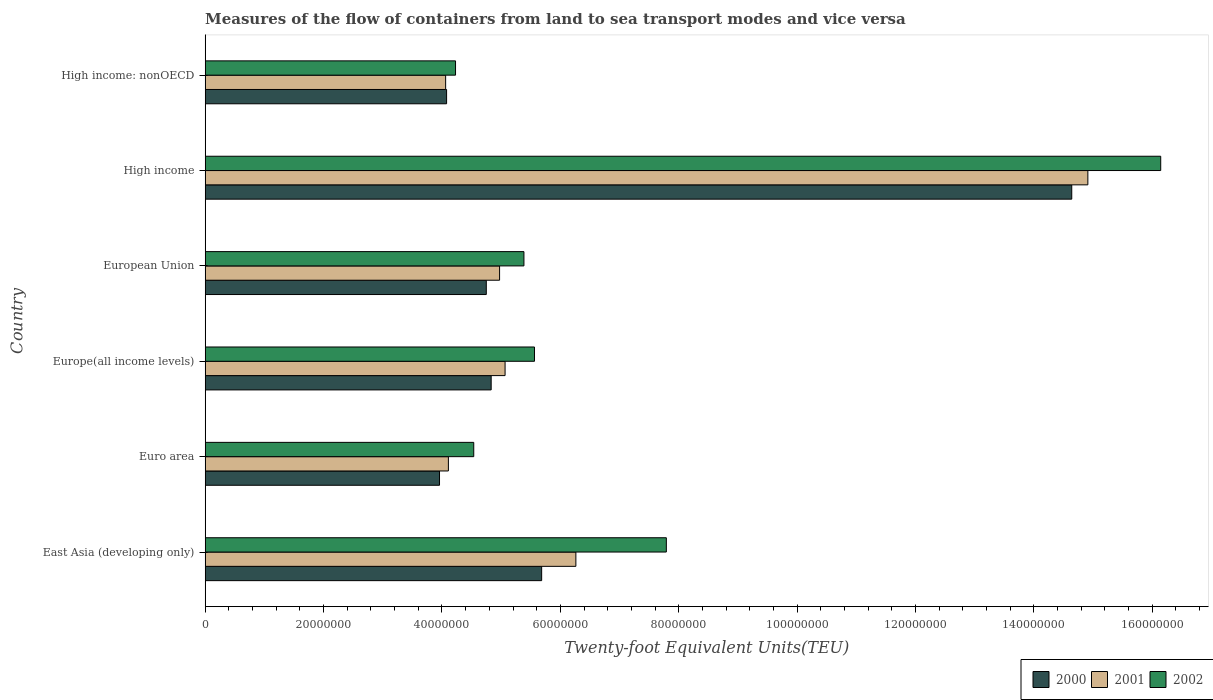How many groups of bars are there?
Give a very brief answer. 6. Are the number of bars per tick equal to the number of legend labels?
Give a very brief answer. Yes. Are the number of bars on each tick of the Y-axis equal?
Ensure brevity in your answer.  Yes. How many bars are there on the 1st tick from the top?
Give a very brief answer. 3. What is the label of the 1st group of bars from the top?
Your answer should be very brief. High income: nonOECD. In how many cases, is the number of bars for a given country not equal to the number of legend labels?
Give a very brief answer. 0. What is the container port traffic in 2000 in Europe(all income levels)?
Offer a very short reply. 4.83e+07. Across all countries, what is the maximum container port traffic in 2001?
Your answer should be very brief. 1.49e+08. Across all countries, what is the minimum container port traffic in 2001?
Offer a terse response. 4.06e+07. In which country was the container port traffic in 2001 minimum?
Offer a very short reply. High income: nonOECD. What is the total container port traffic in 2000 in the graph?
Offer a terse response. 3.79e+08. What is the difference between the container port traffic in 2002 in Euro area and that in High income: nonOECD?
Make the answer very short. 3.08e+06. What is the difference between the container port traffic in 2001 in East Asia (developing only) and the container port traffic in 2002 in High income: nonOECD?
Your response must be concise. 2.03e+07. What is the average container port traffic in 2002 per country?
Your response must be concise. 7.27e+07. What is the difference between the container port traffic in 2000 and container port traffic in 2002 in Europe(all income levels)?
Make the answer very short. -7.32e+06. What is the ratio of the container port traffic in 2002 in Euro area to that in High income?
Your answer should be very brief. 0.28. Is the container port traffic in 2000 in European Union less than that in High income: nonOECD?
Your answer should be compact. No. Is the difference between the container port traffic in 2000 in Euro area and Europe(all income levels) greater than the difference between the container port traffic in 2002 in Euro area and Europe(all income levels)?
Give a very brief answer. Yes. What is the difference between the highest and the second highest container port traffic in 2000?
Provide a succinct answer. 8.96e+07. What is the difference between the highest and the lowest container port traffic in 2000?
Offer a terse response. 1.07e+08. What does the 1st bar from the top in High income represents?
Ensure brevity in your answer.  2002. Is it the case that in every country, the sum of the container port traffic in 2000 and container port traffic in 2002 is greater than the container port traffic in 2001?
Make the answer very short. Yes. How many bars are there?
Your answer should be very brief. 18. Does the graph contain any zero values?
Offer a terse response. No. What is the title of the graph?
Ensure brevity in your answer.  Measures of the flow of containers from land to sea transport modes and vice versa. What is the label or title of the X-axis?
Offer a terse response. Twenty-foot Equivalent Units(TEU). What is the label or title of the Y-axis?
Make the answer very short. Country. What is the Twenty-foot Equivalent Units(TEU) in 2000 in East Asia (developing only)?
Keep it short and to the point. 5.68e+07. What is the Twenty-foot Equivalent Units(TEU) of 2001 in East Asia (developing only)?
Your response must be concise. 6.26e+07. What is the Twenty-foot Equivalent Units(TEU) in 2002 in East Asia (developing only)?
Ensure brevity in your answer.  7.79e+07. What is the Twenty-foot Equivalent Units(TEU) of 2000 in Euro area?
Ensure brevity in your answer.  3.96e+07. What is the Twenty-foot Equivalent Units(TEU) in 2001 in Euro area?
Provide a short and direct response. 4.11e+07. What is the Twenty-foot Equivalent Units(TEU) in 2002 in Euro area?
Offer a terse response. 4.54e+07. What is the Twenty-foot Equivalent Units(TEU) of 2000 in Europe(all income levels)?
Offer a terse response. 4.83e+07. What is the Twenty-foot Equivalent Units(TEU) of 2001 in Europe(all income levels)?
Offer a terse response. 5.07e+07. What is the Twenty-foot Equivalent Units(TEU) of 2002 in Europe(all income levels)?
Provide a short and direct response. 5.56e+07. What is the Twenty-foot Equivalent Units(TEU) in 2000 in European Union?
Provide a succinct answer. 4.75e+07. What is the Twenty-foot Equivalent Units(TEU) of 2001 in European Union?
Offer a terse response. 4.97e+07. What is the Twenty-foot Equivalent Units(TEU) in 2002 in European Union?
Provide a succinct answer. 5.38e+07. What is the Twenty-foot Equivalent Units(TEU) of 2000 in High income?
Keep it short and to the point. 1.46e+08. What is the Twenty-foot Equivalent Units(TEU) in 2001 in High income?
Offer a terse response. 1.49e+08. What is the Twenty-foot Equivalent Units(TEU) of 2002 in High income?
Give a very brief answer. 1.61e+08. What is the Twenty-foot Equivalent Units(TEU) in 2000 in High income: nonOECD?
Your answer should be compact. 4.08e+07. What is the Twenty-foot Equivalent Units(TEU) in 2001 in High income: nonOECD?
Give a very brief answer. 4.06e+07. What is the Twenty-foot Equivalent Units(TEU) in 2002 in High income: nonOECD?
Your response must be concise. 4.23e+07. Across all countries, what is the maximum Twenty-foot Equivalent Units(TEU) in 2000?
Make the answer very short. 1.46e+08. Across all countries, what is the maximum Twenty-foot Equivalent Units(TEU) in 2001?
Give a very brief answer. 1.49e+08. Across all countries, what is the maximum Twenty-foot Equivalent Units(TEU) in 2002?
Your response must be concise. 1.61e+08. Across all countries, what is the minimum Twenty-foot Equivalent Units(TEU) in 2000?
Provide a succinct answer. 3.96e+07. Across all countries, what is the minimum Twenty-foot Equivalent Units(TEU) in 2001?
Give a very brief answer. 4.06e+07. Across all countries, what is the minimum Twenty-foot Equivalent Units(TEU) in 2002?
Provide a succinct answer. 4.23e+07. What is the total Twenty-foot Equivalent Units(TEU) in 2000 in the graph?
Your answer should be very brief. 3.79e+08. What is the total Twenty-foot Equivalent Units(TEU) of 2001 in the graph?
Offer a terse response. 3.94e+08. What is the total Twenty-foot Equivalent Units(TEU) in 2002 in the graph?
Give a very brief answer. 4.36e+08. What is the difference between the Twenty-foot Equivalent Units(TEU) of 2000 in East Asia (developing only) and that in Euro area?
Your answer should be very brief. 1.73e+07. What is the difference between the Twenty-foot Equivalent Units(TEU) in 2001 in East Asia (developing only) and that in Euro area?
Offer a terse response. 2.15e+07. What is the difference between the Twenty-foot Equivalent Units(TEU) of 2002 in East Asia (developing only) and that in Euro area?
Make the answer very short. 3.25e+07. What is the difference between the Twenty-foot Equivalent Units(TEU) of 2000 in East Asia (developing only) and that in Europe(all income levels)?
Provide a short and direct response. 8.53e+06. What is the difference between the Twenty-foot Equivalent Units(TEU) in 2001 in East Asia (developing only) and that in Europe(all income levels)?
Offer a terse response. 1.20e+07. What is the difference between the Twenty-foot Equivalent Units(TEU) of 2002 in East Asia (developing only) and that in Europe(all income levels)?
Offer a terse response. 2.23e+07. What is the difference between the Twenty-foot Equivalent Units(TEU) of 2000 in East Asia (developing only) and that in European Union?
Your answer should be compact. 9.35e+06. What is the difference between the Twenty-foot Equivalent Units(TEU) in 2001 in East Asia (developing only) and that in European Union?
Your answer should be compact. 1.29e+07. What is the difference between the Twenty-foot Equivalent Units(TEU) in 2002 in East Asia (developing only) and that in European Union?
Give a very brief answer. 2.41e+07. What is the difference between the Twenty-foot Equivalent Units(TEU) in 2000 in East Asia (developing only) and that in High income?
Your answer should be very brief. -8.96e+07. What is the difference between the Twenty-foot Equivalent Units(TEU) of 2001 in East Asia (developing only) and that in High income?
Ensure brevity in your answer.  -8.65e+07. What is the difference between the Twenty-foot Equivalent Units(TEU) in 2002 in East Asia (developing only) and that in High income?
Keep it short and to the point. -8.35e+07. What is the difference between the Twenty-foot Equivalent Units(TEU) in 2000 in East Asia (developing only) and that in High income: nonOECD?
Make the answer very short. 1.61e+07. What is the difference between the Twenty-foot Equivalent Units(TEU) of 2001 in East Asia (developing only) and that in High income: nonOECD?
Your response must be concise. 2.20e+07. What is the difference between the Twenty-foot Equivalent Units(TEU) in 2002 in East Asia (developing only) and that in High income: nonOECD?
Your answer should be very brief. 3.56e+07. What is the difference between the Twenty-foot Equivalent Units(TEU) in 2000 in Euro area and that in Europe(all income levels)?
Your answer should be very brief. -8.73e+06. What is the difference between the Twenty-foot Equivalent Units(TEU) in 2001 in Euro area and that in Europe(all income levels)?
Offer a very short reply. -9.58e+06. What is the difference between the Twenty-foot Equivalent Units(TEU) of 2002 in Euro area and that in Europe(all income levels)?
Offer a very short reply. -1.03e+07. What is the difference between the Twenty-foot Equivalent Units(TEU) in 2000 in Euro area and that in European Union?
Provide a succinct answer. -7.90e+06. What is the difference between the Twenty-foot Equivalent Units(TEU) of 2001 in Euro area and that in European Union?
Provide a short and direct response. -8.65e+06. What is the difference between the Twenty-foot Equivalent Units(TEU) in 2002 in Euro area and that in European Union?
Give a very brief answer. -8.48e+06. What is the difference between the Twenty-foot Equivalent Units(TEU) in 2000 in Euro area and that in High income?
Your response must be concise. -1.07e+08. What is the difference between the Twenty-foot Equivalent Units(TEU) in 2001 in Euro area and that in High income?
Keep it short and to the point. -1.08e+08. What is the difference between the Twenty-foot Equivalent Units(TEU) of 2002 in Euro area and that in High income?
Provide a succinct answer. -1.16e+08. What is the difference between the Twenty-foot Equivalent Units(TEU) of 2000 in Euro area and that in High income: nonOECD?
Offer a very short reply. -1.20e+06. What is the difference between the Twenty-foot Equivalent Units(TEU) of 2001 in Euro area and that in High income: nonOECD?
Your answer should be very brief. 4.64e+05. What is the difference between the Twenty-foot Equivalent Units(TEU) of 2002 in Euro area and that in High income: nonOECD?
Offer a very short reply. 3.08e+06. What is the difference between the Twenty-foot Equivalent Units(TEU) in 2000 in Europe(all income levels) and that in European Union?
Provide a short and direct response. 8.26e+05. What is the difference between the Twenty-foot Equivalent Units(TEU) in 2001 in Europe(all income levels) and that in European Union?
Offer a very short reply. 9.30e+05. What is the difference between the Twenty-foot Equivalent Units(TEU) in 2002 in Europe(all income levels) and that in European Union?
Provide a succinct answer. 1.78e+06. What is the difference between the Twenty-foot Equivalent Units(TEU) of 2000 in Europe(all income levels) and that in High income?
Your answer should be compact. -9.81e+07. What is the difference between the Twenty-foot Equivalent Units(TEU) of 2001 in Europe(all income levels) and that in High income?
Provide a short and direct response. -9.85e+07. What is the difference between the Twenty-foot Equivalent Units(TEU) in 2002 in Europe(all income levels) and that in High income?
Give a very brief answer. -1.06e+08. What is the difference between the Twenty-foot Equivalent Units(TEU) in 2000 in Europe(all income levels) and that in High income: nonOECD?
Ensure brevity in your answer.  7.53e+06. What is the difference between the Twenty-foot Equivalent Units(TEU) in 2001 in Europe(all income levels) and that in High income: nonOECD?
Make the answer very short. 1.00e+07. What is the difference between the Twenty-foot Equivalent Units(TEU) of 2002 in Europe(all income levels) and that in High income: nonOECD?
Your answer should be very brief. 1.33e+07. What is the difference between the Twenty-foot Equivalent Units(TEU) of 2000 in European Union and that in High income?
Your answer should be very brief. -9.89e+07. What is the difference between the Twenty-foot Equivalent Units(TEU) of 2001 in European Union and that in High income?
Ensure brevity in your answer.  -9.94e+07. What is the difference between the Twenty-foot Equivalent Units(TEU) in 2002 in European Union and that in High income?
Your answer should be very brief. -1.08e+08. What is the difference between the Twenty-foot Equivalent Units(TEU) of 2000 in European Union and that in High income: nonOECD?
Provide a succinct answer. 6.71e+06. What is the difference between the Twenty-foot Equivalent Units(TEU) of 2001 in European Union and that in High income: nonOECD?
Make the answer very short. 9.11e+06. What is the difference between the Twenty-foot Equivalent Units(TEU) of 2002 in European Union and that in High income: nonOECD?
Keep it short and to the point. 1.16e+07. What is the difference between the Twenty-foot Equivalent Units(TEU) of 2000 in High income and that in High income: nonOECD?
Give a very brief answer. 1.06e+08. What is the difference between the Twenty-foot Equivalent Units(TEU) of 2001 in High income and that in High income: nonOECD?
Make the answer very short. 1.08e+08. What is the difference between the Twenty-foot Equivalent Units(TEU) of 2002 in High income and that in High income: nonOECD?
Ensure brevity in your answer.  1.19e+08. What is the difference between the Twenty-foot Equivalent Units(TEU) in 2000 in East Asia (developing only) and the Twenty-foot Equivalent Units(TEU) in 2001 in Euro area?
Offer a very short reply. 1.58e+07. What is the difference between the Twenty-foot Equivalent Units(TEU) in 2000 in East Asia (developing only) and the Twenty-foot Equivalent Units(TEU) in 2002 in Euro area?
Provide a succinct answer. 1.15e+07. What is the difference between the Twenty-foot Equivalent Units(TEU) in 2001 in East Asia (developing only) and the Twenty-foot Equivalent Units(TEU) in 2002 in Euro area?
Your response must be concise. 1.73e+07. What is the difference between the Twenty-foot Equivalent Units(TEU) in 2000 in East Asia (developing only) and the Twenty-foot Equivalent Units(TEU) in 2001 in Europe(all income levels)?
Provide a short and direct response. 6.18e+06. What is the difference between the Twenty-foot Equivalent Units(TEU) of 2000 in East Asia (developing only) and the Twenty-foot Equivalent Units(TEU) of 2002 in Europe(all income levels)?
Your answer should be very brief. 1.21e+06. What is the difference between the Twenty-foot Equivalent Units(TEU) of 2001 in East Asia (developing only) and the Twenty-foot Equivalent Units(TEU) of 2002 in Europe(all income levels)?
Provide a succinct answer. 6.99e+06. What is the difference between the Twenty-foot Equivalent Units(TEU) of 2000 in East Asia (developing only) and the Twenty-foot Equivalent Units(TEU) of 2001 in European Union?
Offer a very short reply. 7.11e+06. What is the difference between the Twenty-foot Equivalent Units(TEU) in 2000 in East Asia (developing only) and the Twenty-foot Equivalent Units(TEU) in 2002 in European Union?
Provide a succinct answer. 3.00e+06. What is the difference between the Twenty-foot Equivalent Units(TEU) of 2001 in East Asia (developing only) and the Twenty-foot Equivalent Units(TEU) of 2002 in European Union?
Offer a terse response. 8.78e+06. What is the difference between the Twenty-foot Equivalent Units(TEU) in 2000 in East Asia (developing only) and the Twenty-foot Equivalent Units(TEU) in 2001 in High income?
Offer a very short reply. -9.23e+07. What is the difference between the Twenty-foot Equivalent Units(TEU) of 2000 in East Asia (developing only) and the Twenty-foot Equivalent Units(TEU) of 2002 in High income?
Your answer should be very brief. -1.05e+08. What is the difference between the Twenty-foot Equivalent Units(TEU) in 2001 in East Asia (developing only) and the Twenty-foot Equivalent Units(TEU) in 2002 in High income?
Provide a succinct answer. -9.88e+07. What is the difference between the Twenty-foot Equivalent Units(TEU) of 2000 in East Asia (developing only) and the Twenty-foot Equivalent Units(TEU) of 2001 in High income: nonOECD?
Keep it short and to the point. 1.62e+07. What is the difference between the Twenty-foot Equivalent Units(TEU) of 2000 in East Asia (developing only) and the Twenty-foot Equivalent Units(TEU) of 2002 in High income: nonOECD?
Give a very brief answer. 1.45e+07. What is the difference between the Twenty-foot Equivalent Units(TEU) in 2001 in East Asia (developing only) and the Twenty-foot Equivalent Units(TEU) in 2002 in High income: nonOECD?
Ensure brevity in your answer.  2.03e+07. What is the difference between the Twenty-foot Equivalent Units(TEU) of 2000 in Euro area and the Twenty-foot Equivalent Units(TEU) of 2001 in Europe(all income levels)?
Provide a succinct answer. -1.11e+07. What is the difference between the Twenty-foot Equivalent Units(TEU) of 2000 in Euro area and the Twenty-foot Equivalent Units(TEU) of 2002 in Europe(all income levels)?
Offer a very short reply. -1.60e+07. What is the difference between the Twenty-foot Equivalent Units(TEU) in 2001 in Euro area and the Twenty-foot Equivalent Units(TEU) in 2002 in Europe(all income levels)?
Offer a terse response. -1.45e+07. What is the difference between the Twenty-foot Equivalent Units(TEU) of 2000 in Euro area and the Twenty-foot Equivalent Units(TEU) of 2001 in European Union?
Offer a very short reply. -1.01e+07. What is the difference between the Twenty-foot Equivalent Units(TEU) in 2000 in Euro area and the Twenty-foot Equivalent Units(TEU) in 2002 in European Union?
Offer a very short reply. -1.43e+07. What is the difference between the Twenty-foot Equivalent Units(TEU) of 2001 in Euro area and the Twenty-foot Equivalent Units(TEU) of 2002 in European Union?
Your answer should be very brief. -1.28e+07. What is the difference between the Twenty-foot Equivalent Units(TEU) in 2000 in Euro area and the Twenty-foot Equivalent Units(TEU) in 2001 in High income?
Your answer should be very brief. -1.10e+08. What is the difference between the Twenty-foot Equivalent Units(TEU) of 2000 in Euro area and the Twenty-foot Equivalent Units(TEU) of 2002 in High income?
Your answer should be very brief. -1.22e+08. What is the difference between the Twenty-foot Equivalent Units(TEU) in 2001 in Euro area and the Twenty-foot Equivalent Units(TEU) in 2002 in High income?
Ensure brevity in your answer.  -1.20e+08. What is the difference between the Twenty-foot Equivalent Units(TEU) of 2000 in Euro area and the Twenty-foot Equivalent Units(TEU) of 2001 in High income: nonOECD?
Your response must be concise. -1.04e+06. What is the difference between the Twenty-foot Equivalent Units(TEU) in 2000 in Euro area and the Twenty-foot Equivalent Units(TEU) in 2002 in High income: nonOECD?
Your answer should be compact. -2.71e+06. What is the difference between the Twenty-foot Equivalent Units(TEU) in 2001 in Euro area and the Twenty-foot Equivalent Units(TEU) in 2002 in High income: nonOECD?
Offer a terse response. -1.21e+06. What is the difference between the Twenty-foot Equivalent Units(TEU) in 2000 in Europe(all income levels) and the Twenty-foot Equivalent Units(TEU) in 2001 in European Union?
Your answer should be compact. -1.42e+06. What is the difference between the Twenty-foot Equivalent Units(TEU) in 2000 in Europe(all income levels) and the Twenty-foot Equivalent Units(TEU) in 2002 in European Union?
Keep it short and to the point. -5.53e+06. What is the difference between the Twenty-foot Equivalent Units(TEU) of 2001 in Europe(all income levels) and the Twenty-foot Equivalent Units(TEU) of 2002 in European Union?
Ensure brevity in your answer.  -3.19e+06. What is the difference between the Twenty-foot Equivalent Units(TEU) of 2000 in Europe(all income levels) and the Twenty-foot Equivalent Units(TEU) of 2001 in High income?
Offer a very short reply. -1.01e+08. What is the difference between the Twenty-foot Equivalent Units(TEU) in 2000 in Europe(all income levels) and the Twenty-foot Equivalent Units(TEU) in 2002 in High income?
Make the answer very short. -1.13e+08. What is the difference between the Twenty-foot Equivalent Units(TEU) in 2001 in Europe(all income levels) and the Twenty-foot Equivalent Units(TEU) in 2002 in High income?
Ensure brevity in your answer.  -1.11e+08. What is the difference between the Twenty-foot Equivalent Units(TEU) of 2000 in Europe(all income levels) and the Twenty-foot Equivalent Units(TEU) of 2001 in High income: nonOECD?
Make the answer very short. 7.69e+06. What is the difference between the Twenty-foot Equivalent Units(TEU) of 2000 in Europe(all income levels) and the Twenty-foot Equivalent Units(TEU) of 2002 in High income: nonOECD?
Your answer should be compact. 6.02e+06. What is the difference between the Twenty-foot Equivalent Units(TEU) of 2001 in Europe(all income levels) and the Twenty-foot Equivalent Units(TEU) of 2002 in High income: nonOECD?
Make the answer very short. 8.37e+06. What is the difference between the Twenty-foot Equivalent Units(TEU) in 2000 in European Union and the Twenty-foot Equivalent Units(TEU) in 2001 in High income?
Offer a terse response. -1.02e+08. What is the difference between the Twenty-foot Equivalent Units(TEU) of 2000 in European Union and the Twenty-foot Equivalent Units(TEU) of 2002 in High income?
Offer a terse response. -1.14e+08. What is the difference between the Twenty-foot Equivalent Units(TEU) of 2001 in European Union and the Twenty-foot Equivalent Units(TEU) of 2002 in High income?
Ensure brevity in your answer.  -1.12e+08. What is the difference between the Twenty-foot Equivalent Units(TEU) in 2000 in European Union and the Twenty-foot Equivalent Units(TEU) in 2001 in High income: nonOECD?
Offer a terse response. 6.87e+06. What is the difference between the Twenty-foot Equivalent Units(TEU) in 2000 in European Union and the Twenty-foot Equivalent Units(TEU) in 2002 in High income: nonOECD?
Your response must be concise. 5.19e+06. What is the difference between the Twenty-foot Equivalent Units(TEU) in 2001 in European Union and the Twenty-foot Equivalent Units(TEU) in 2002 in High income: nonOECD?
Your answer should be very brief. 7.44e+06. What is the difference between the Twenty-foot Equivalent Units(TEU) in 2000 in High income and the Twenty-foot Equivalent Units(TEU) in 2001 in High income: nonOECD?
Your answer should be compact. 1.06e+08. What is the difference between the Twenty-foot Equivalent Units(TEU) of 2000 in High income and the Twenty-foot Equivalent Units(TEU) of 2002 in High income: nonOECD?
Your answer should be very brief. 1.04e+08. What is the difference between the Twenty-foot Equivalent Units(TEU) in 2001 in High income and the Twenty-foot Equivalent Units(TEU) in 2002 in High income: nonOECD?
Keep it short and to the point. 1.07e+08. What is the average Twenty-foot Equivalent Units(TEU) of 2000 per country?
Offer a terse response. 6.32e+07. What is the average Twenty-foot Equivalent Units(TEU) of 2001 per country?
Keep it short and to the point. 6.56e+07. What is the average Twenty-foot Equivalent Units(TEU) of 2002 per country?
Your answer should be very brief. 7.27e+07. What is the difference between the Twenty-foot Equivalent Units(TEU) of 2000 and Twenty-foot Equivalent Units(TEU) of 2001 in East Asia (developing only)?
Ensure brevity in your answer.  -5.78e+06. What is the difference between the Twenty-foot Equivalent Units(TEU) in 2000 and Twenty-foot Equivalent Units(TEU) in 2002 in East Asia (developing only)?
Ensure brevity in your answer.  -2.11e+07. What is the difference between the Twenty-foot Equivalent Units(TEU) of 2001 and Twenty-foot Equivalent Units(TEU) of 2002 in East Asia (developing only)?
Offer a terse response. -1.53e+07. What is the difference between the Twenty-foot Equivalent Units(TEU) in 2000 and Twenty-foot Equivalent Units(TEU) in 2001 in Euro area?
Your answer should be compact. -1.50e+06. What is the difference between the Twenty-foot Equivalent Units(TEU) in 2000 and Twenty-foot Equivalent Units(TEU) in 2002 in Euro area?
Your response must be concise. -5.78e+06. What is the difference between the Twenty-foot Equivalent Units(TEU) in 2001 and Twenty-foot Equivalent Units(TEU) in 2002 in Euro area?
Ensure brevity in your answer.  -4.28e+06. What is the difference between the Twenty-foot Equivalent Units(TEU) of 2000 and Twenty-foot Equivalent Units(TEU) of 2001 in Europe(all income levels)?
Offer a terse response. -2.35e+06. What is the difference between the Twenty-foot Equivalent Units(TEU) of 2000 and Twenty-foot Equivalent Units(TEU) of 2002 in Europe(all income levels)?
Keep it short and to the point. -7.32e+06. What is the difference between the Twenty-foot Equivalent Units(TEU) of 2001 and Twenty-foot Equivalent Units(TEU) of 2002 in Europe(all income levels)?
Offer a terse response. -4.97e+06. What is the difference between the Twenty-foot Equivalent Units(TEU) of 2000 and Twenty-foot Equivalent Units(TEU) of 2001 in European Union?
Keep it short and to the point. -2.24e+06. What is the difference between the Twenty-foot Equivalent Units(TEU) of 2000 and Twenty-foot Equivalent Units(TEU) of 2002 in European Union?
Give a very brief answer. -6.36e+06. What is the difference between the Twenty-foot Equivalent Units(TEU) of 2001 and Twenty-foot Equivalent Units(TEU) of 2002 in European Union?
Offer a very short reply. -4.11e+06. What is the difference between the Twenty-foot Equivalent Units(TEU) of 2000 and Twenty-foot Equivalent Units(TEU) of 2001 in High income?
Your response must be concise. -2.72e+06. What is the difference between the Twenty-foot Equivalent Units(TEU) of 2000 and Twenty-foot Equivalent Units(TEU) of 2002 in High income?
Provide a succinct answer. -1.50e+07. What is the difference between the Twenty-foot Equivalent Units(TEU) in 2001 and Twenty-foot Equivalent Units(TEU) in 2002 in High income?
Your answer should be compact. -1.23e+07. What is the difference between the Twenty-foot Equivalent Units(TEU) in 2000 and Twenty-foot Equivalent Units(TEU) in 2001 in High income: nonOECD?
Provide a succinct answer. 1.60e+05. What is the difference between the Twenty-foot Equivalent Units(TEU) in 2000 and Twenty-foot Equivalent Units(TEU) in 2002 in High income: nonOECD?
Offer a terse response. -1.51e+06. What is the difference between the Twenty-foot Equivalent Units(TEU) in 2001 and Twenty-foot Equivalent Units(TEU) in 2002 in High income: nonOECD?
Keep it short and to the point. -1.67e+06. What is the ratio of the Twenty-foot Equivalent Units(TEU) of 2000 in East Asia (developing only) to that in Euro area?
Give a very brief answer. 1.44. What is the ratio of the Twenty-foot Equivalent Units(TEU) in 2001 in East Asia (developing only) to that in Euro area?
Offer a very short reply. 1.52. What is the ratio of the Twenty-foot Equivalent Units(TEU) in 2002 in East Asia (developing only) to that in Euro area?
Keep it short and to the point. 1.72. What is the ratio of the Twenty-foot Equivalent Units(TEU) in 2000 in East Asia (developing only) to that in Europe(all income levels)?
Your answer should be compact. 1.18. What is the ratio of the Twenty-foot Equivalent Units(TEU) in 2001 in East Asia (developing only) to that in Europe(all income levels)?
Ensure brevity in your answer.  1.24. What is the ratio of the Twenty-foot Equivalent Units(TEU) in 2002 in East Asia (developing only) to that in Europe(all income levels)?
Provide a short and direct response. 1.4. What is the ratio of the Twenty-foot Equivalent Units(TEU) in 2000 in East Asia (developing only) to that in European Union?
Your answer should be very brief. 1.2. What is the ratio of the Twenty-foot Equivalent Units(TEU) in 2001 in East Asia (developing only) to that in European Union?
Your response must be concise. 1.26. What is the ratio of the Twenty-foot Equivalent Units(TEU) in 2002 in East Asia (developing only) to that in European Union?
Keep it short and to the point. 1.45. What is the ratio of the Twenty-foot Equivalent Units(TEU) of 2000 in East Asia (developing only) to that in High income?
Your answer should be very brief. 0.39. What is the ratio of the Twenty-foot Equivalent Units(TEU) of 2001 in East Asia (developing only) to that in High income?
Provide a succinct answer. 0.42. What is the ratio of the Twenty-foot Equivalent Units(TEU) of 2002 in East Asia (developing only) to that in High income?
Keep it short and to the point. 0.48. What is the ratio of the Twenty-foot Equivalent Units(TEU) in 2000 in East Asia (developing only) to that in High income: nonOECD?
Give a very brief answer. 1.39. What is the ratio of the Twenty-foot Equivalent Units(TEU) of 2001 in East Asia (developing only) to that in High income: nonOECD?
Offer a terse response. 1.54. What is the ratio of the Twenty-foot Equivalent Units(TEU) in 2002 in East Asia (developing only) to that in High income: nonOECD?
Make the answer very short. 1.84. What is the ratio of the Twenty-foot Equivalent Units(TEU) of 2000 in Euro area to that in Europe(all income levels)?
Ensure brevity in your answer.  0.82. What is the ratio of the Twenty-foot Equivalent Units(TEU) of 2001 in Euro area to that in Europe(all income levels)?
Your answer should be very brief. 0.81. What is the ratio of the Twenty-foot Equivalent Units(TEU) of 2002 in Euro area to that in Europe(all income levels)?
Provide a succinct answer. 0.82. What is the ratio of the Twenty-foot Equivalent Units(TEU) of 2000 in Euro area to that in European Union?
Your response must be concise. 0.83. What is the ratio of the Twenty-foot Equivalent Units(TEU) of 2001 in Euro area to that in European Union?
Give a very brief answer. 0.83. What is the ratio of the Twenty-foot Equivalent Units(TEU) of 2002 in Euro area to that in European Union?
Keep it short and to the point. 0.84. What is the ratio of the Twenty-foot Equivalent Units(TEU) in 2000 in Euro area to that in High income?
Offer a terse response. 0.27. What is the ratio of the Twenty-foot Equivalent Units(TEU) in 2001 in Euro area to that in High income?
Offer a very short reply. 0.28. What is the ratio of the Twenty-foot Equivalent Units(TEU) of 2002 in Euro area to that in High income?
Offer a very short reply. 0.28. What is the ratio of the Twenty-foot Equivalent Units(TEU) in 2000 in Euro area to that in High income: nonOECD?
Offer a very short reply. 0.97. What is the ratio of the Twenty-foot Equivalent Units(TEU) in 2001 in Euro area to that in High income: nonOECD?
Provide a succinct answer. 1.01. What is the ratio of the Twenty-foot Equivalent Units(TEU) in 2002 in Euro area to that in High income: nonOECD?
Keep it short and to the point. 1.07. What is the ratio of the Twenty-foot Equivalent Units(TEU) of 2000 in Europe(all income levels) to that in European Union?
Ensure brevity in your answer.  1.02. What is the ratio of the Twenty-foot Equivalent Units(TEU) of 2001 in Europe(all income levels) to that in European Union?
Provide a succinct answer. 1.02. What is the ratio of the Twenty-foot Equivalent Units(TEU) of 2002 in Europe(all income levels) to that in European Union?
Your answer should be very brief. 1.03. What is the ratio of the Twenty-foot Equivalent Units(TEU) of 2000 in Europe(all income levels) to that in High income?
Provide a short and direct response. 0.33. What is the ratio of the Twenty-foot Equivalent Units(TEU) in 2001 in Europe(all income levels) to that in High income?
Provide a succinct answer. 0.34. What is the ratio of the Twenty-foot Equivalent Units(TEU) in 2002 in Europe(all income levels) to that in High income?
Ensure brevity in your answer.  0.34. What is the ratio of the Twenty-foot Equivalent Units(TEU) of 2000 in Europe(all income levels) to that in High income: nonOECD?
Ensure brevity in your answer.  1.18. What is the ratio of the Twenty-foot Equivalent Units(TEU) in 2001 in Europe(all income levels) to that in High income: nonOECD?
Provide a short and direct response. 1.25. What is the ratio of the Twenty-foot Equivalent Units(TEU) of 2002 in Europe(all income levels) to that in High income: nonOECD?
Your response must be concise. 1.32. What is the ratio of the Twenty-foot Equivalent Units(TEU) in 2000 in European Union to that in High income?
Your answer should be compact. 0.32. What is the ratio of the Twenty-foot Equivalent Units(TEU) of 2001 in European Union to that in High income?
Your answer should be very brief. 0.33. What is the ratio of the Twenty-foot Equivalent Units(TEU) in 2002 in European Union to that in High income?
Ensure brevity in your answer.  0.33. What is the ratio of the Twenty-foot Equivalent Units(TEU) in 2000 in European Union to that in High income: nonOECD?
Provide a short and direct response. 1.16. What is the ratio of the Twenty-foot Equivalent Units(TEU) in 2001 in European Union to that in High income: nonOECD?
Your answer should be compact. 1.22. What is the ratio of the Twenty-foot Equivalent Units(TEU) of 2002 in European Union to that in High income: nonOECD?
Your answer should be compact. 1.27. What is the ratio of the Twenty-foot Equivalent Units(TEU) in 2000 in High income to that in High income: nonOECD?
Provide a succinct answer. 3.59. What is the ratio of the Twenty-foot Equivalent Units(TEU) of 2001 in High income to that in High income: nonOECD?
Keep it short and to the point. 3.67. What is the ratio of the Twenty-foot Equivalent Units(TEU) of 2002 in High income to that in High income: nonOECD?
Your answer should be compact. 3.82. What is the difference between the highest and the second highest Twenty-foot Equivalent Units(TEU) of 2000?
Your response must be concise. 8.96e+07. What is the difference between the highest and the second highest Twenty-foot Equivalent Units(TEU) of 2001?
Provide a succinct answer. 8.65e+07. What is the difference between the highest and the second highest Twenty-foot Equivalent Units(TEU) of 2002?
Provide a succinct answer. 8.35e+07. What is the difference between the highest and the lowest Twenty-foot Equivalent Units(TEU) of 2000?
Your response must be concise. 1.07e+08. What is the difference between the highest and the lowest Twenty-foot Equivalent Units(TEU) of 2001?
Give a very brief answer. 1.08e+08. What is the difference between the highest and the lowest Twenty-foot Equivalent Units(TEU) of 2002?
Offer a terse response. 1.19e+08. 